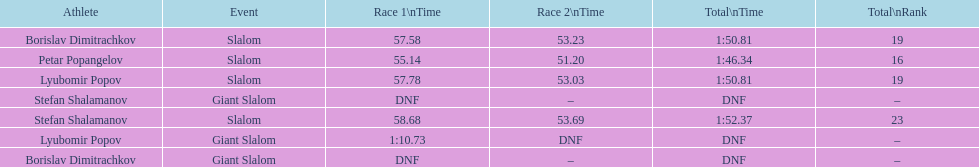Who has the highest rank? Petar Popangelov. 